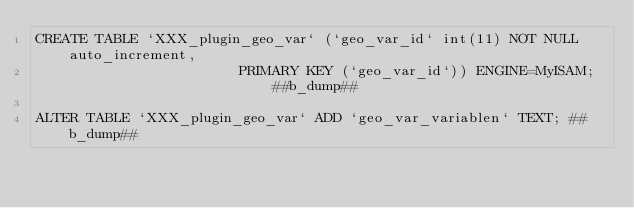Convert code to text. <code><loc_0><loc_0><loc_500><loc_500><_SQL_>CREATE TABLE `XXX_plugin_geo_var` (`geo_var_id` int(11) NOT NULL auto_increment,
				  							PRIMARY KEY (`geo_var_id`)) ENGINE=MyISAM; ##b_dump##

ALTER TABLE `XXX_plugin_geo_var` ADD `geo_var_variablen` TEXT; ##b_dump##

</code> 